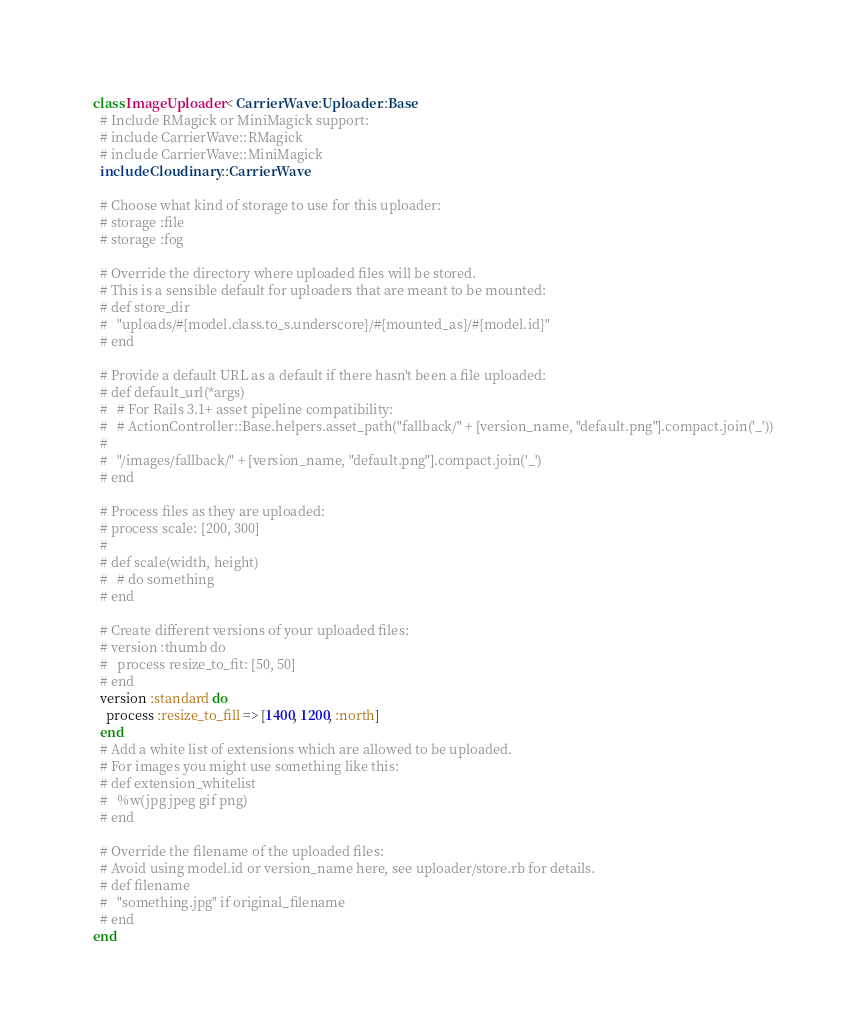Convert code to text. <code><loc_0><loc_0><loc_500><loc_500><_Ruby_>class ImageUploader < CarrierWave::Uploader::Base
  # Include RMagick or MiniMagick support:
  # include CarrierWave::RMagick
  # include CarrierWave::MiniMagick
  include Cloudinary::CarrierWave

  # Choose what kind of storage to use for this uploader:
  # storage :file
  # storage :fog

  # Override the directory where uploaded files will be stored.
  # This is a sensible default for uploaders that are meant to be mounted:
  # def store_dir
  #   "uploads/#{model.class.to_s.underscore}/#{mounted_as}/#{model.id}"
  # end

  # Provide a default URL as a default if there hasn't been a file uploaded:
  # def default_url(*args)
  #   # For Rails 3.1+ asset pipeline compatibility:
  #   # ActionController::Base.helpers.asset_path("fallback/" + [version_name, "default.png"].compact.join('_'))
  #
  #   "/images/fallback/" + [version_name, "default.png"].compact.join('_')
  # end

  # Process files as they are uploaded:
  # process scale: [200, 300]
  #
  # def scale(width, height)
  #   # do something
  # end

  # Create different versions of your uploaded files:
  # version :thumb do
  #   process resize_to_fit: [50, 50]
  # end
  version :standard do
    process :resize_to_fill => [1400, 1200, :north]
  end
  # Add a white list of extensions which are allowed to be uploaded.
  # For images you might use something like this:
  # def extension_whitelist
  #   %w(jpg jpeg gif png)
  # end

  # Override the filename of the uploaded files:
  # Avoid using model.id or version_name here, see uploader/store.rb for details.
  # def filename
  #   "something.jpg" if original_filename
  # end
end
</code> 